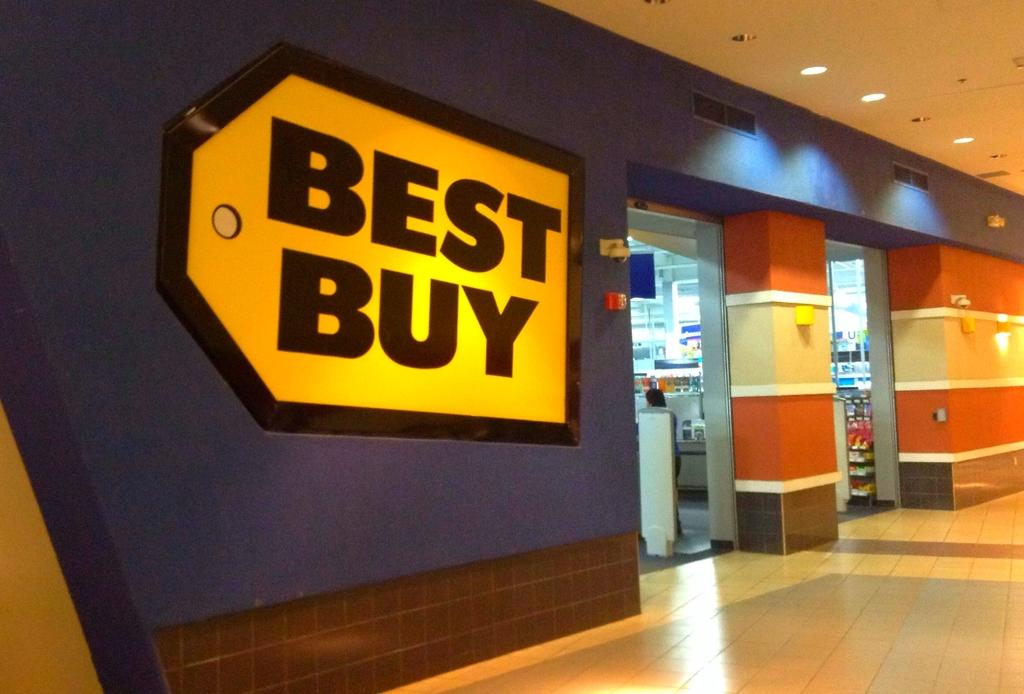Provide a one-sentence caption for the provided image. Best buy store that sell electronics and more. 